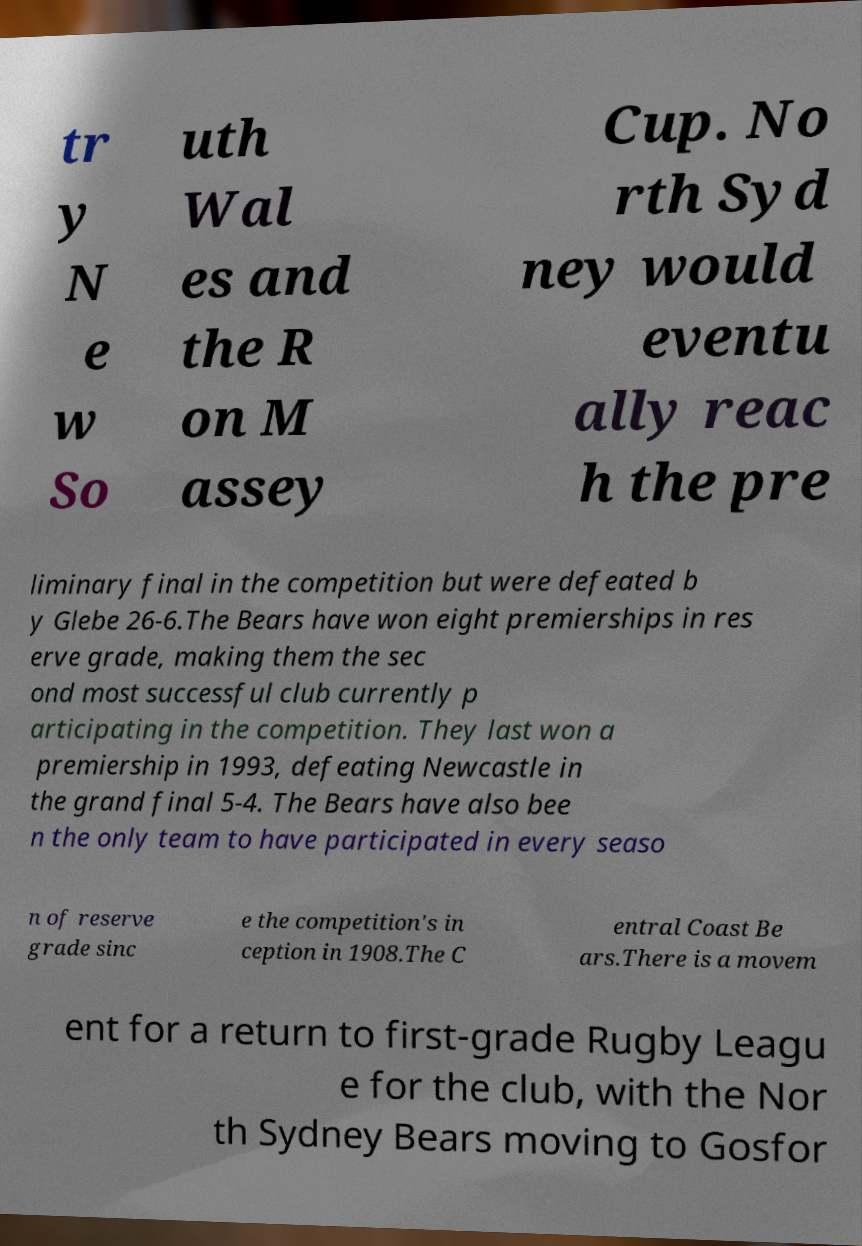Please read and relay the text visible in this image. What does it say? tr y N e w So uth Wal es and the R on M assey Cup. No rth Syd ney would eventu ally reac h the pre liminary final in the competition but were defeated b y Glebe 26-6.The Bears have won eight premierships in res erve grade, making them the sec ond most successful club currently p articipating in the competition. They last won a premiership in 1993, defeating Newcastle in the grand final 5-4. The Bears have also bee n the only team to have participated in every seaso n of reserve grade sinc e the competition's in ception in 1908.The C entral Coast Be ars.There is a movem ent for a return to first-grade Rugby Leagu e for the club, with the Nor th Sydney Bears moving to Gosfor 